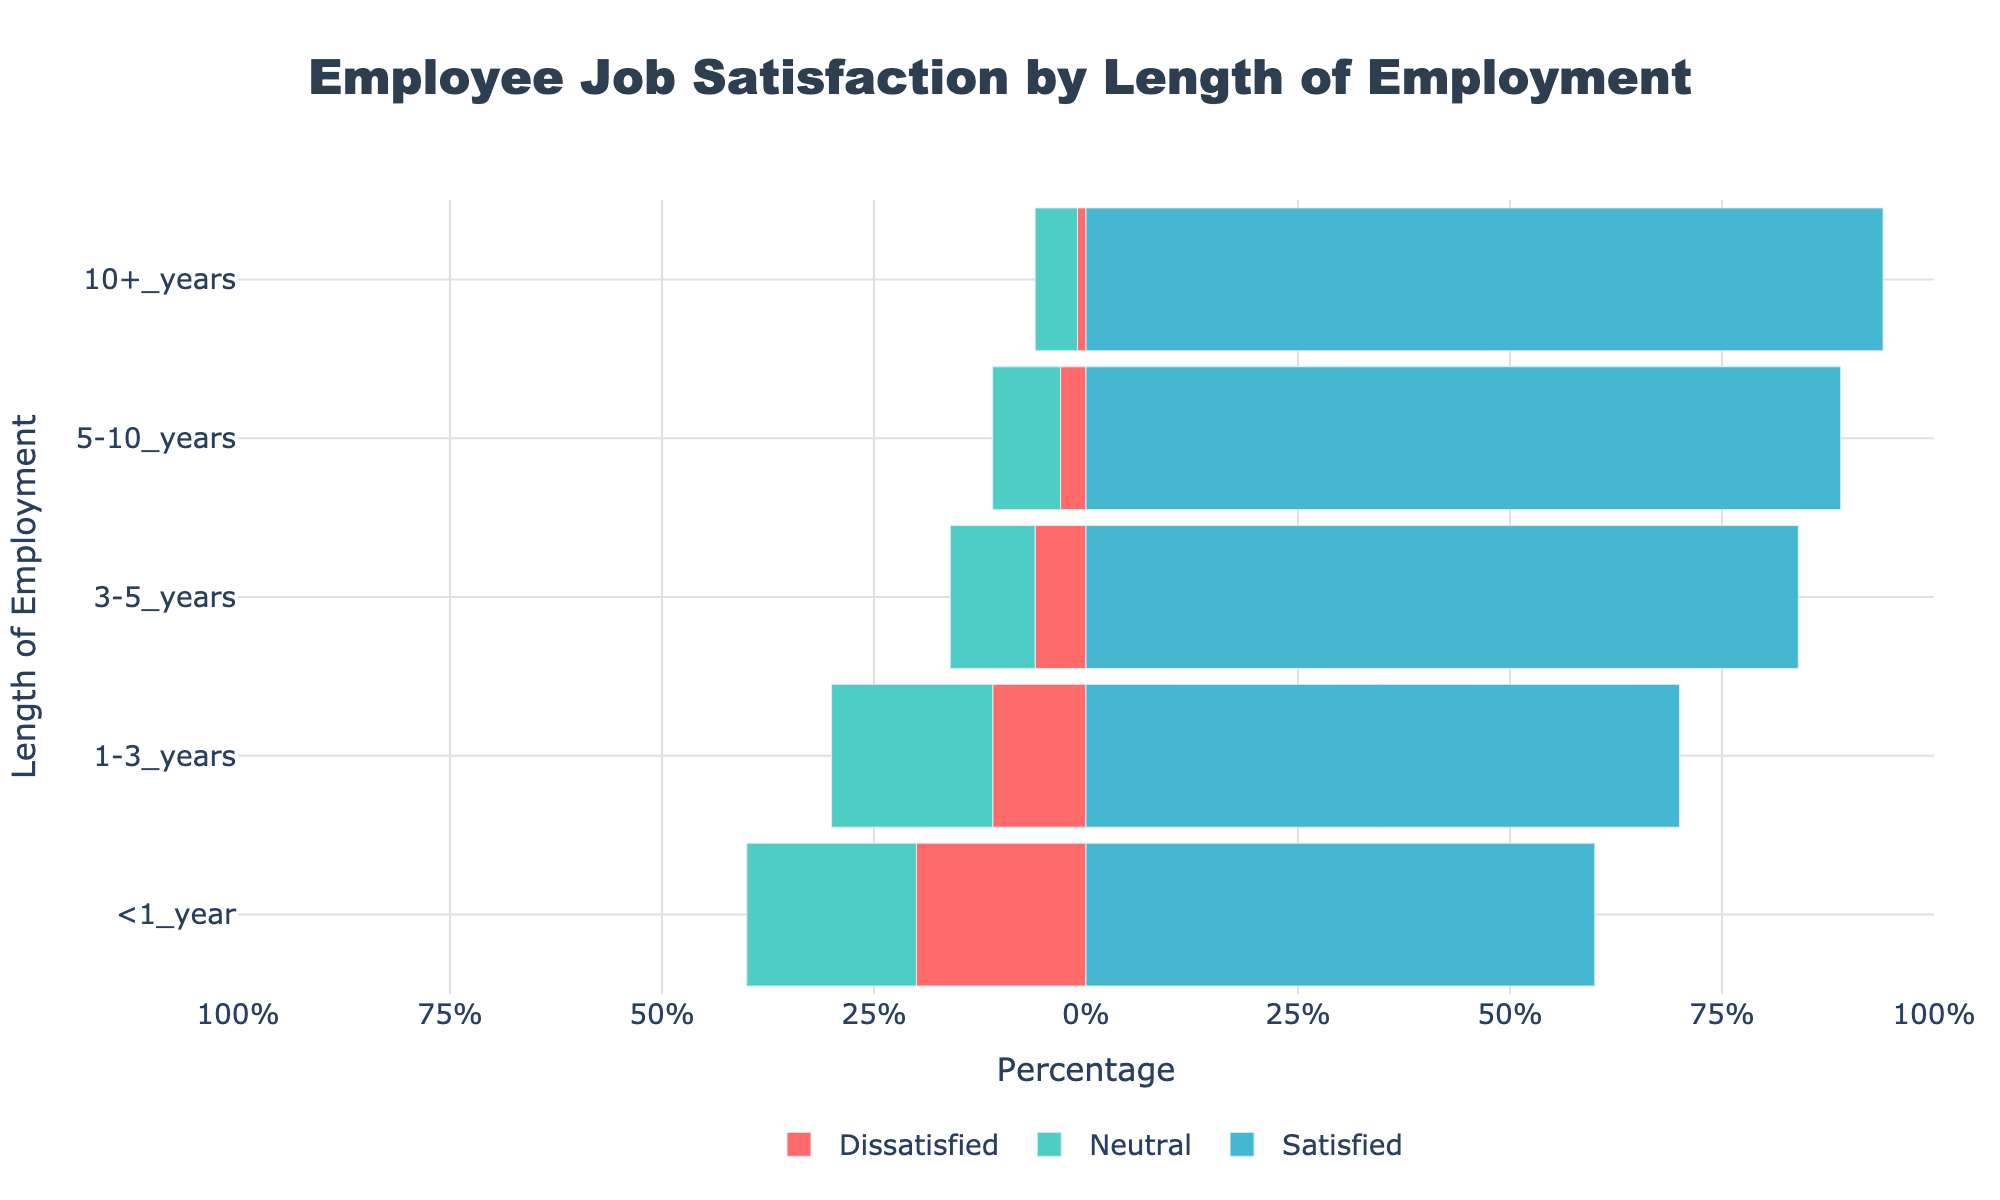How many employees in the 1-3 years group are Neutral or Dissatisfied? Add the Neutral count (19) to the Dissatisfied count (8) of the 1-3 years group: 19 + 8 = 27
Answer: 27 Which employment length group has the highest percentage of Very Satisfied employees? Compare the lengths by their Very Satisfied percentages: <1 year (25%), 1-3 years (25%), 3-5 years (34%), 5-10 years (49%), 10+ years (59%). The group with the highest value is 10+ years.
Answer: 10+ years How does the proportion of Satisfied employees change as the length of employment increases from <1 year to 10+ years? Examine the Satisfied percentages: <1 year (35%), 1-3 years (45%), 3-5 years (50%), 5-10 years (40%), 10+ years (35%). The proportion initially increases, peaks at 3-5 years, then slightly decreases, and finally stabilizes in the longest group.
Answer: Peaks at 3-5 years What is the combined percentage of Satisfied and Very Satisfied employees in the 5-10 years group? Add the Satisfied (40%) and Very Satisfied (49%) percentages of the 5-10 years group: 40% + 49% = 89%.
Answer: 89% Which employment length group shows the lowest dissatisfaction (combining Dissatisfied and Very Dissatisfied)? Sum the Dissatisfied and Very Dissatisfied percentages for each group and identify the group with the smallest value: <1 year (20%), 1-3 years (11%), 3-5 years (6%), 5-10 years (3%), 10+ years (1%). The lowest value is for 10+ years.
Answer: 10+ years Can you identify a trend in the Neutral response as the length of employment increases? Examine the Neutral percentages: <1 year (20%), 1-3 years (19%), 3-5 years (10%), 5-10 years (8%), 10+ years (5%). There is a clear decreasing trend in Neutral responses as employment length increases.
Answer: Decreasing By how much does the percentage of Very Satisfied employees differ between the groups 3-5 years and 10+ years? Subtract the Very Satisfied percentage of the 3-5 years group (34%) from that of the 10+ years group (59%): 59% - 34% = 25%.
Answer: 25% Which group has a nearly equal percentage of Satisfied and Very Satisfied employees? Compare the percentages of Satisfied and Very Satisfied for near equality: <1 year (35% and 25%), 1-3 years (45% and 25%), 3-5 years (50% and 34%), 5-10 years (40% and 49%), 10+ years (35% and 59%). The closest is <1 year with 35% and 25%.
Answer: <1 year 